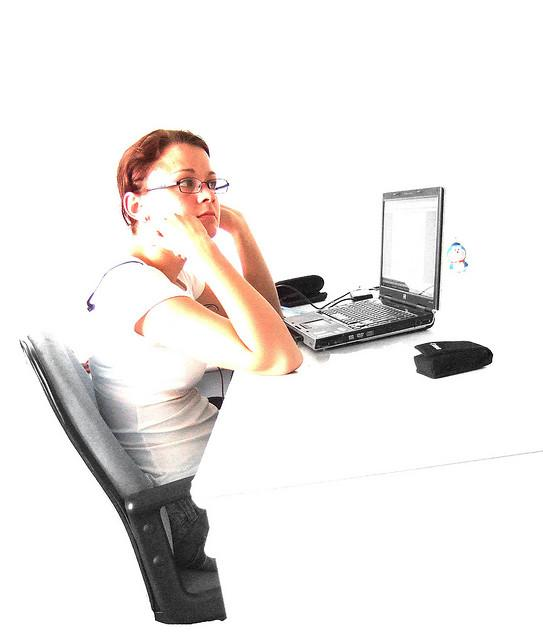Why is the woman sitting down?

Choices:
A) to paint
B) to work
C) to sew
D) to eat to work 